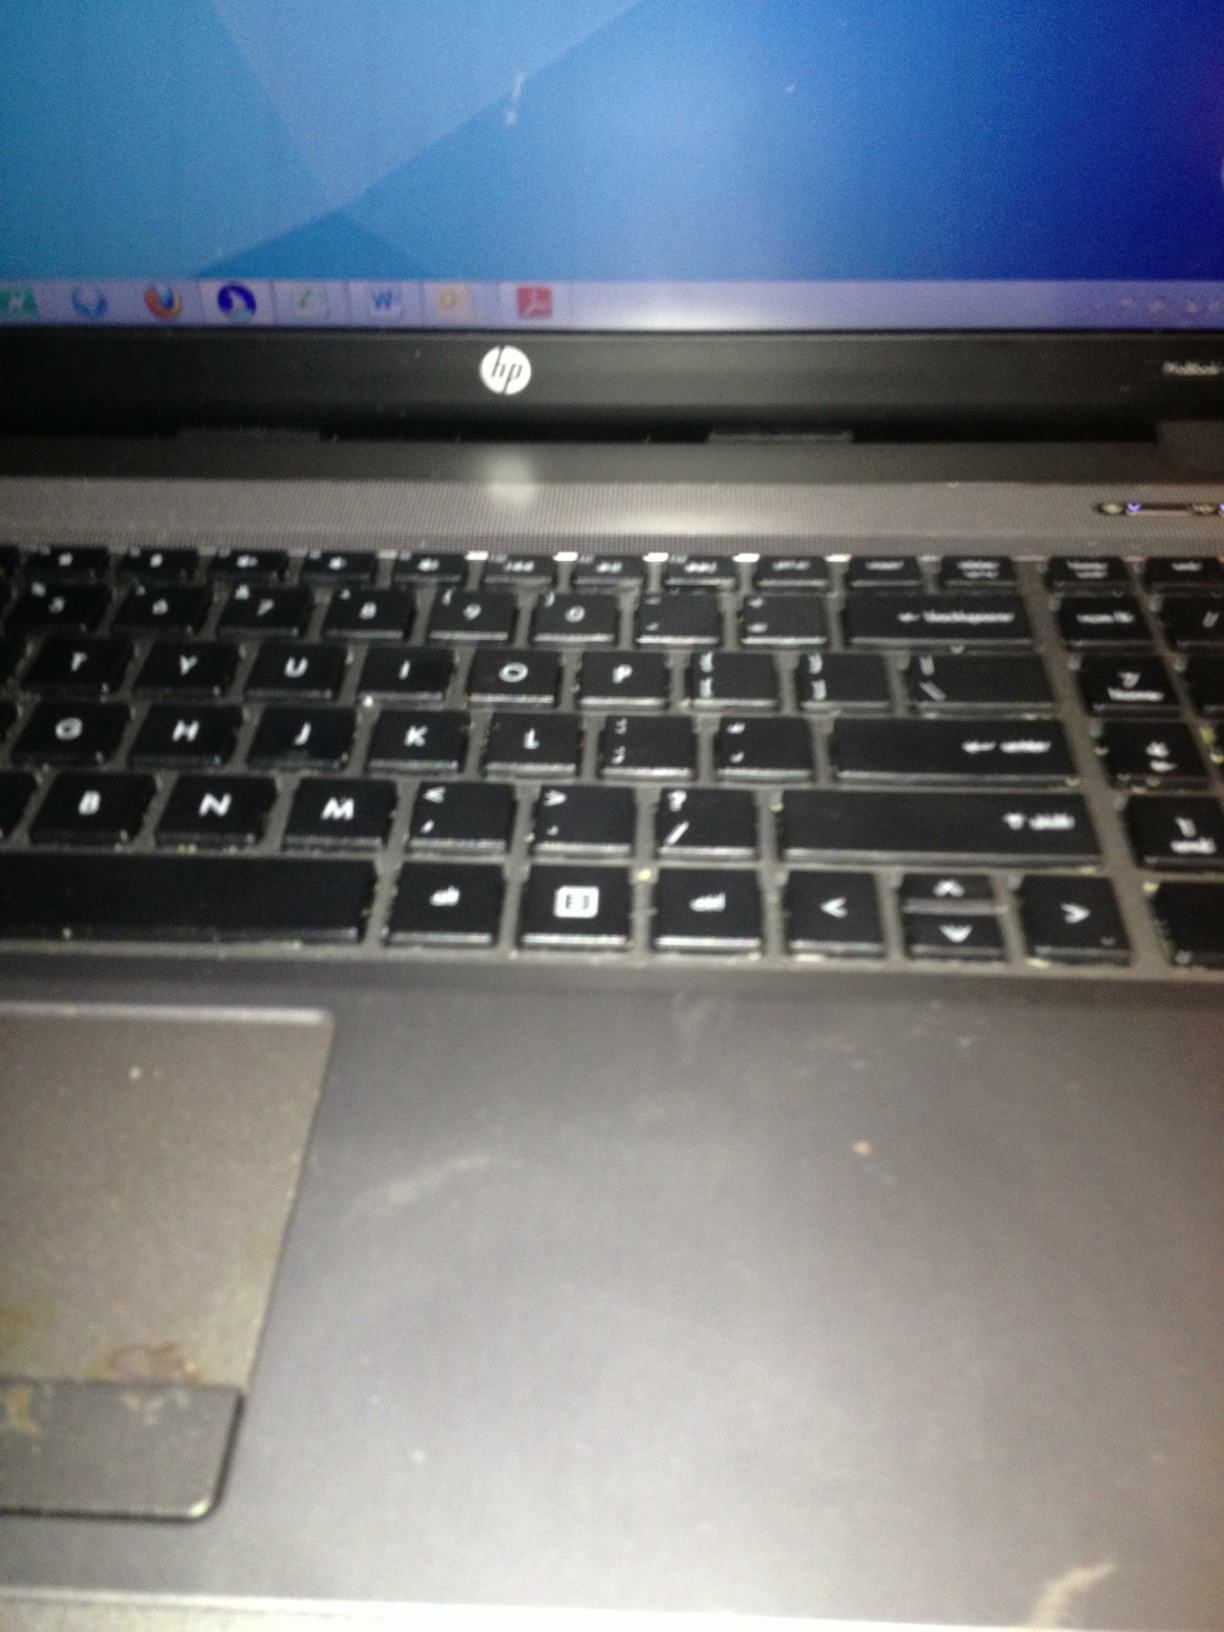Can you tell me about the condition of this laptop and any visible wear and tear? From the image provided, there appears to be a visible amount of wear and tear on this HP laptop, particularly in the form of wear on the keyboard and touchpad area. The laptop looks like it has been heavily used. It might be helpful to clean the surface to see if the condition can be improved. 